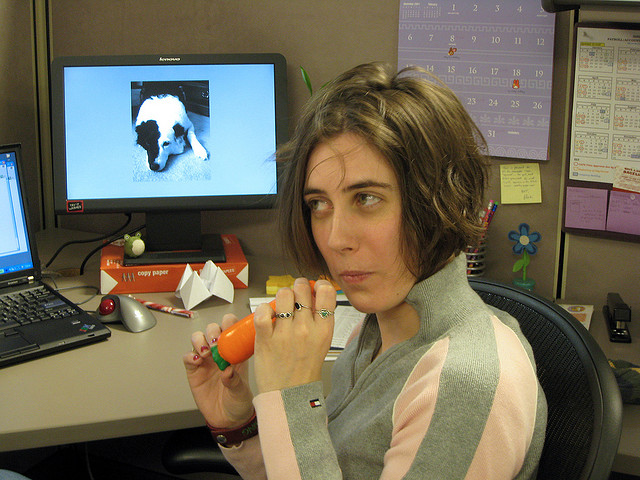<image>What is the sharp object the person has in their hand? It is unknown what the sharp object the person has in their hand is. It could be a balloon, a carrot, a toy carrot, a pin, a pen, or a plastic carrot. What is the sharp object the person has in their hand? It is unknown what sharp object the person has in their hand. It can be seen a balloon, carrot, toy carrot, pin, pen, or plastic carrot. 